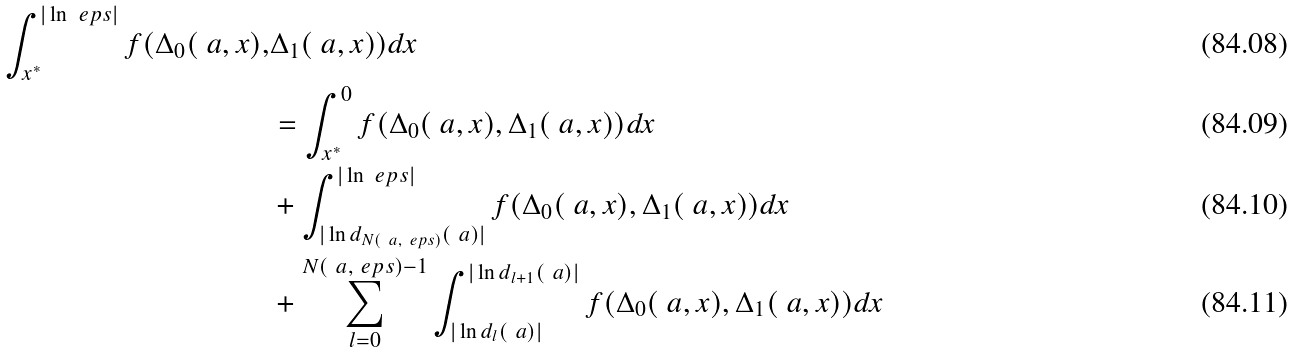Convert formula to latex. <formula><loc_0><loc_0><loc_500><loc_500>\int _ { x ^ { * } } ^ { | \ln \ e p s | } f ( \Delta _ { 0 } ( \ a , x ) , & \Delta _ { 1 } ( \ a , x ) ) d x \\ & = \int _ { x ^ { * } } ^ { 0 } f ( \Delta _ { 0 } ( \ a , x ) , \Delta _ { 1 } ( \ a , x ) ) d x \\ & + \int _ { | \ln d _ { N ( \ a , \ e p s ) } ( \ a ) | } ^ { | \ln \ e p s | } f ( \Delta _ { 0 } ( \ a , x ) , \Delta _ { 1 } ( \ a , x ) ) d x \\ & + \sum _ { l = 0 } ^ { N ( \ a , \ e p s ) - 1 } \int _ { | \ln d _ { l } ( \ a ) | } ^ { | \ln d _ { l + 1 } ( \ a ) | } f ( \Delta _ { 0 } ( \ a , x ) , \Delta _ { 1 } ( \ a , x ) ) d x</formula> 